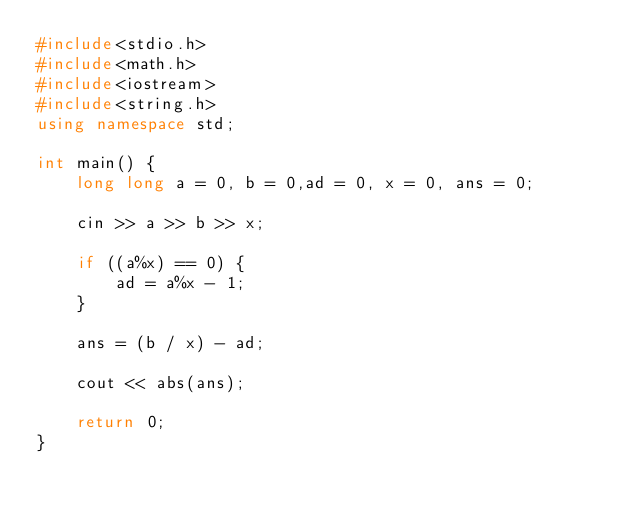Convert code to text. <code><loc_0><loc_0><loc_500><loc_500><_C++_>#include<stdio.h>
#include<math.h>
#include<iostream>
#include<string.h>
using namespace std;

int main() {
	long long a = 0, b = 0,ad = 0, x = 0, ans = 0;

	cin >> a >> b >> x;

	if ((a%x) == 0) {
		ad = a%x - 1;
	}

	ans = (b / x) - ad;

	cout << abs(ans);

	return 0;
}</code> 